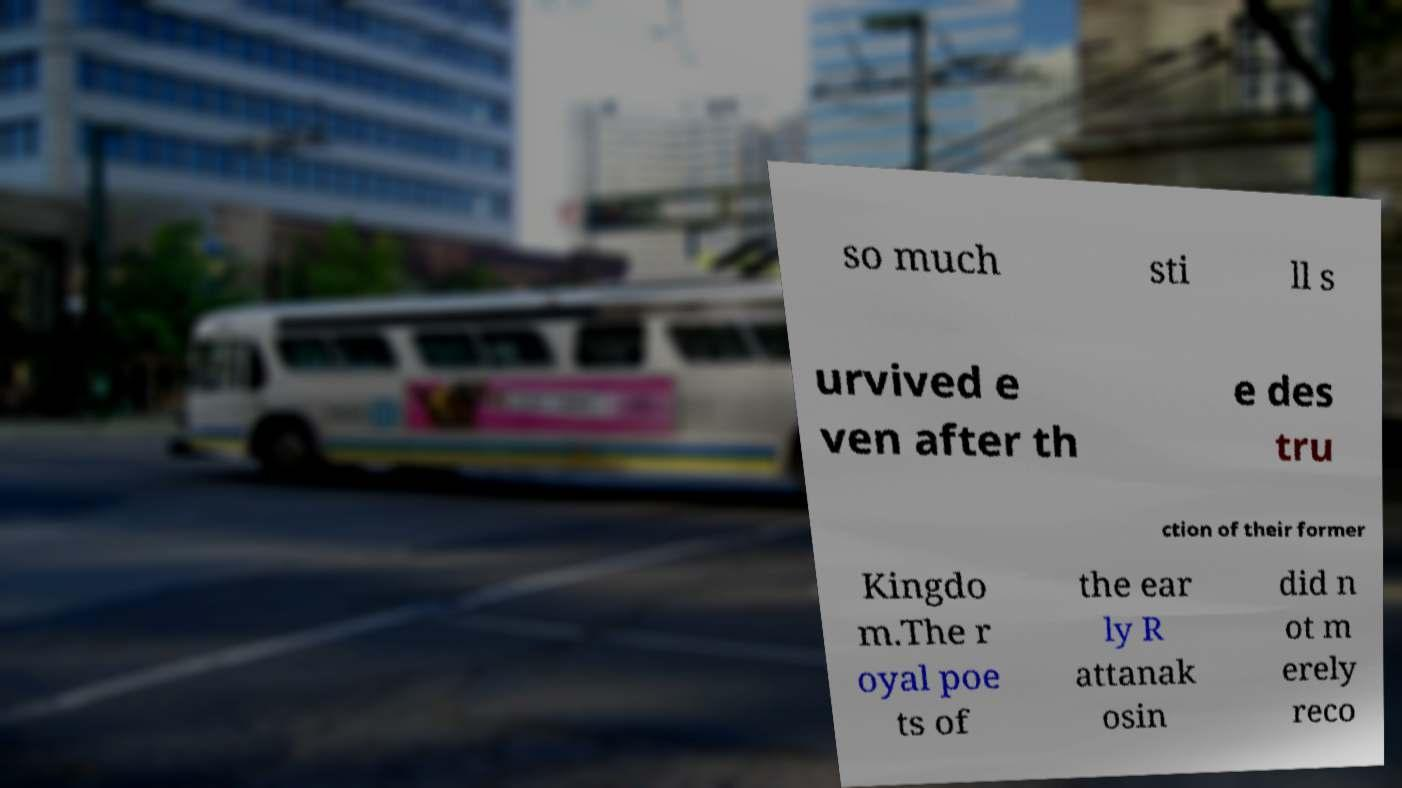Could you extract and type out the text from this image? so much sti ll s urvived e ven after th e des tru ction of their former Kingdo m.The r oyal poe ts of the ear ly R attanak osin did n ot m erely reco 